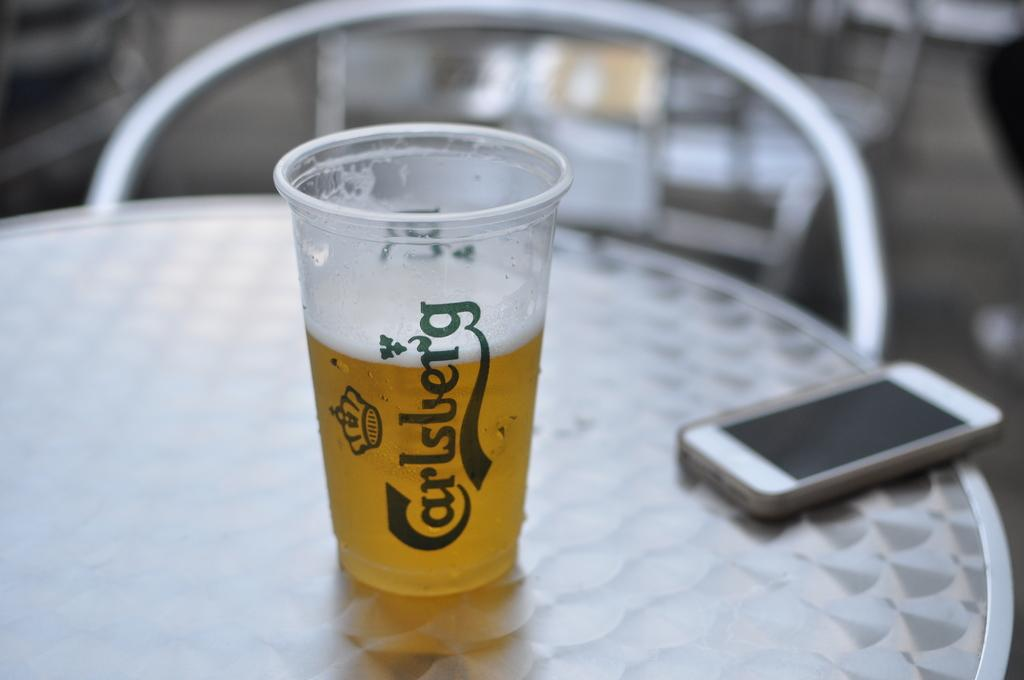<image>
Give a short and clear explanation of the subsequent image. A plastic cup of beer with the brand Carlsberg on the side and a cell phone. 